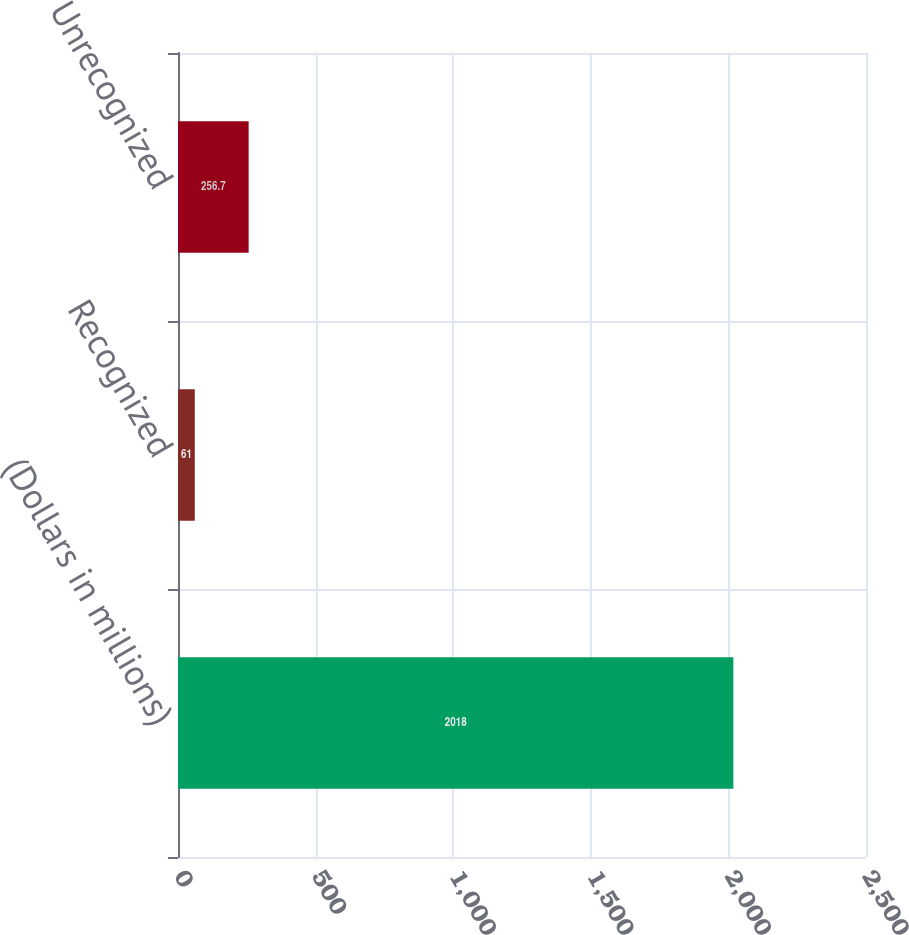Convert chart to OTSL. <chart><loc_0><loc_0><loc_500><loc_500><bar_chart><fcel>(Dollars in millions)<fcel>Recognized<fcel>Unrecognized<nl><fcel>2018<fcel>61<fcel>256.7<nl></chart> 